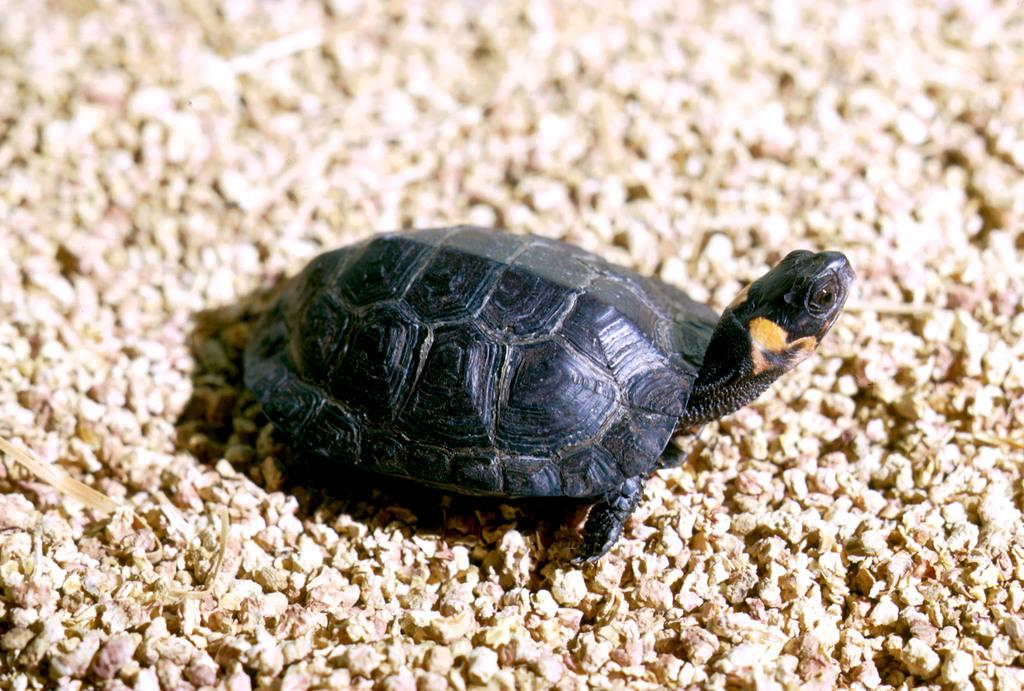What type of animal is in the image? There is a black color turtle in the image. Where is the turtle located in the image? The turtle is on the ground. Is there any specific detail about the image that is not clear? Yes, the image is blurred in this part. What type of development can be seen in the image? There is no development project visible in the image; it features a black color turtle on the ground. How many vans are parked near the turtle in the image? There are no vans present in the image. 